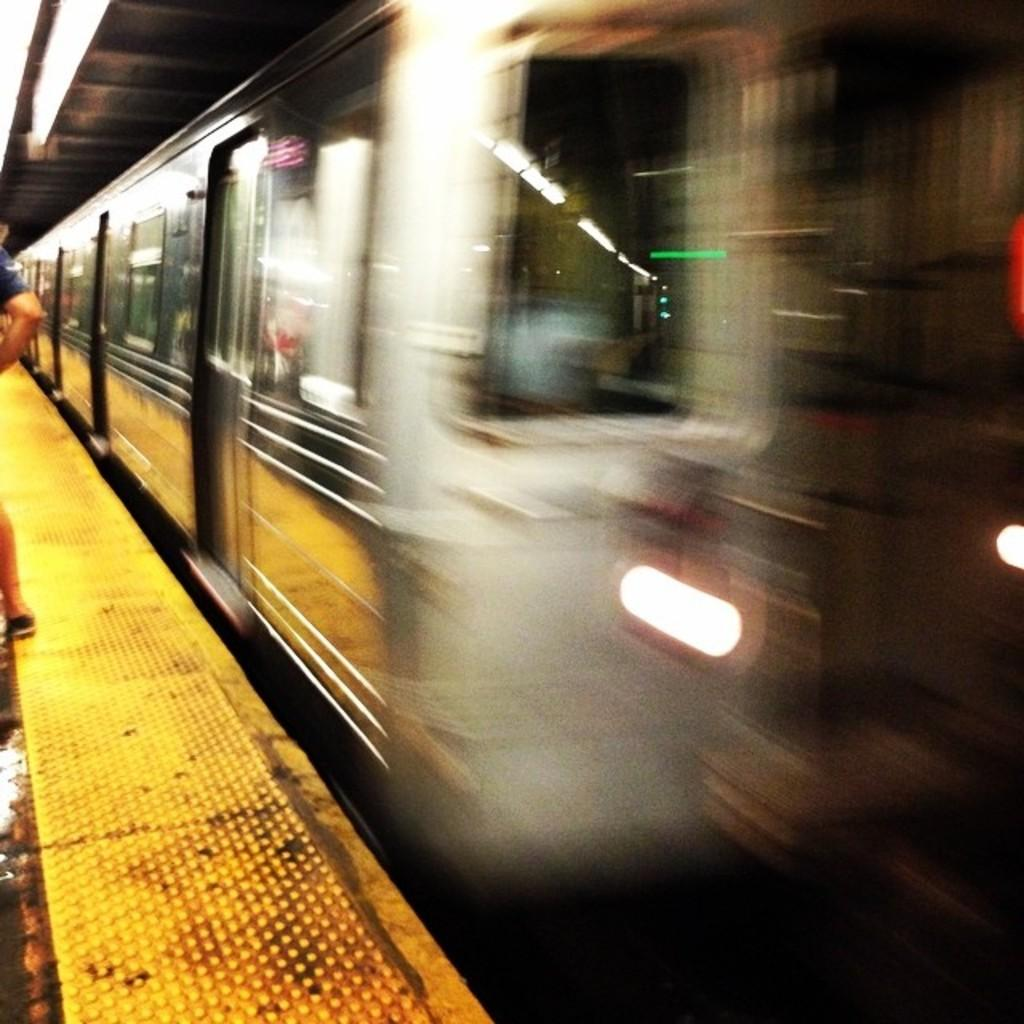What is happening in the image? There is a person standing on the stage in the image. What can be seen in the center of the image? There is a rain with a set of lights in the center of the image. How many babies are sitting on the stove in the image? There are no babies or stoves present in the image. 